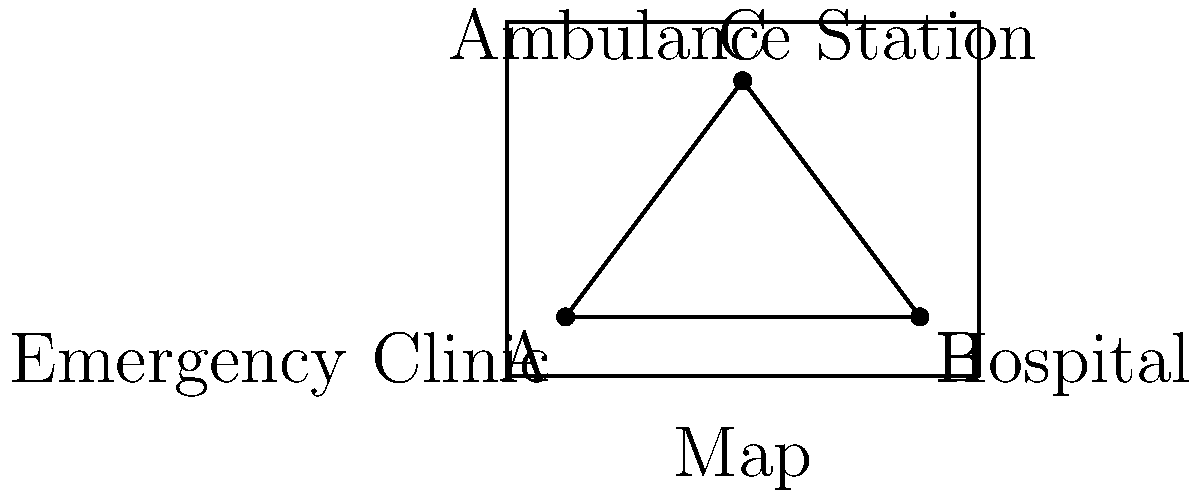As a retired nurse familiar with emergency response, consider a map showing three critical locations: an Emergency Clinic (0,0), a Hospital (6,0), and an Ambulance Station (3,4). These points form a triangle on the map. Calculate the area of this triangle to help understand the coverage of emergency services in the region. Let's approach this step-by-step:

1) We have three points:
   A (Emergency Clinic): (0,0)
   B (Hospital): (6,0)
   C (Ambulance Station): (3,4)

2) To find the area of a triangle given three points, we can use the formula:

   Area = $\frac{1}{2}|x_1(y_2 - y_3) + x_2(y_3 - y_1) + x_3(y_1 - y_2)|$

   Where $(x_1, y_1)$, $(x_2, y_2)$, and $(x_3, y_3)$ are the coordinates of the three points.

3) Let's substitute our values:
   
   Area = $\frac{1}{2}|0(0 - 4) + 6(4 - 0) + 3(0 - 0)|$

4) Simplify:
   
   Area = $\frac{1}{2}|0 + 24 + 0|$

5) Calculate:
   
   Area = $\frac{1}{2}|24| = \frac{1}{2}(24) = 12$

6) The units would be square units on the map. In a real-world scenario, this could represent square miles or square kilometers, depending on the map's scale.
Answer: 12 square units 